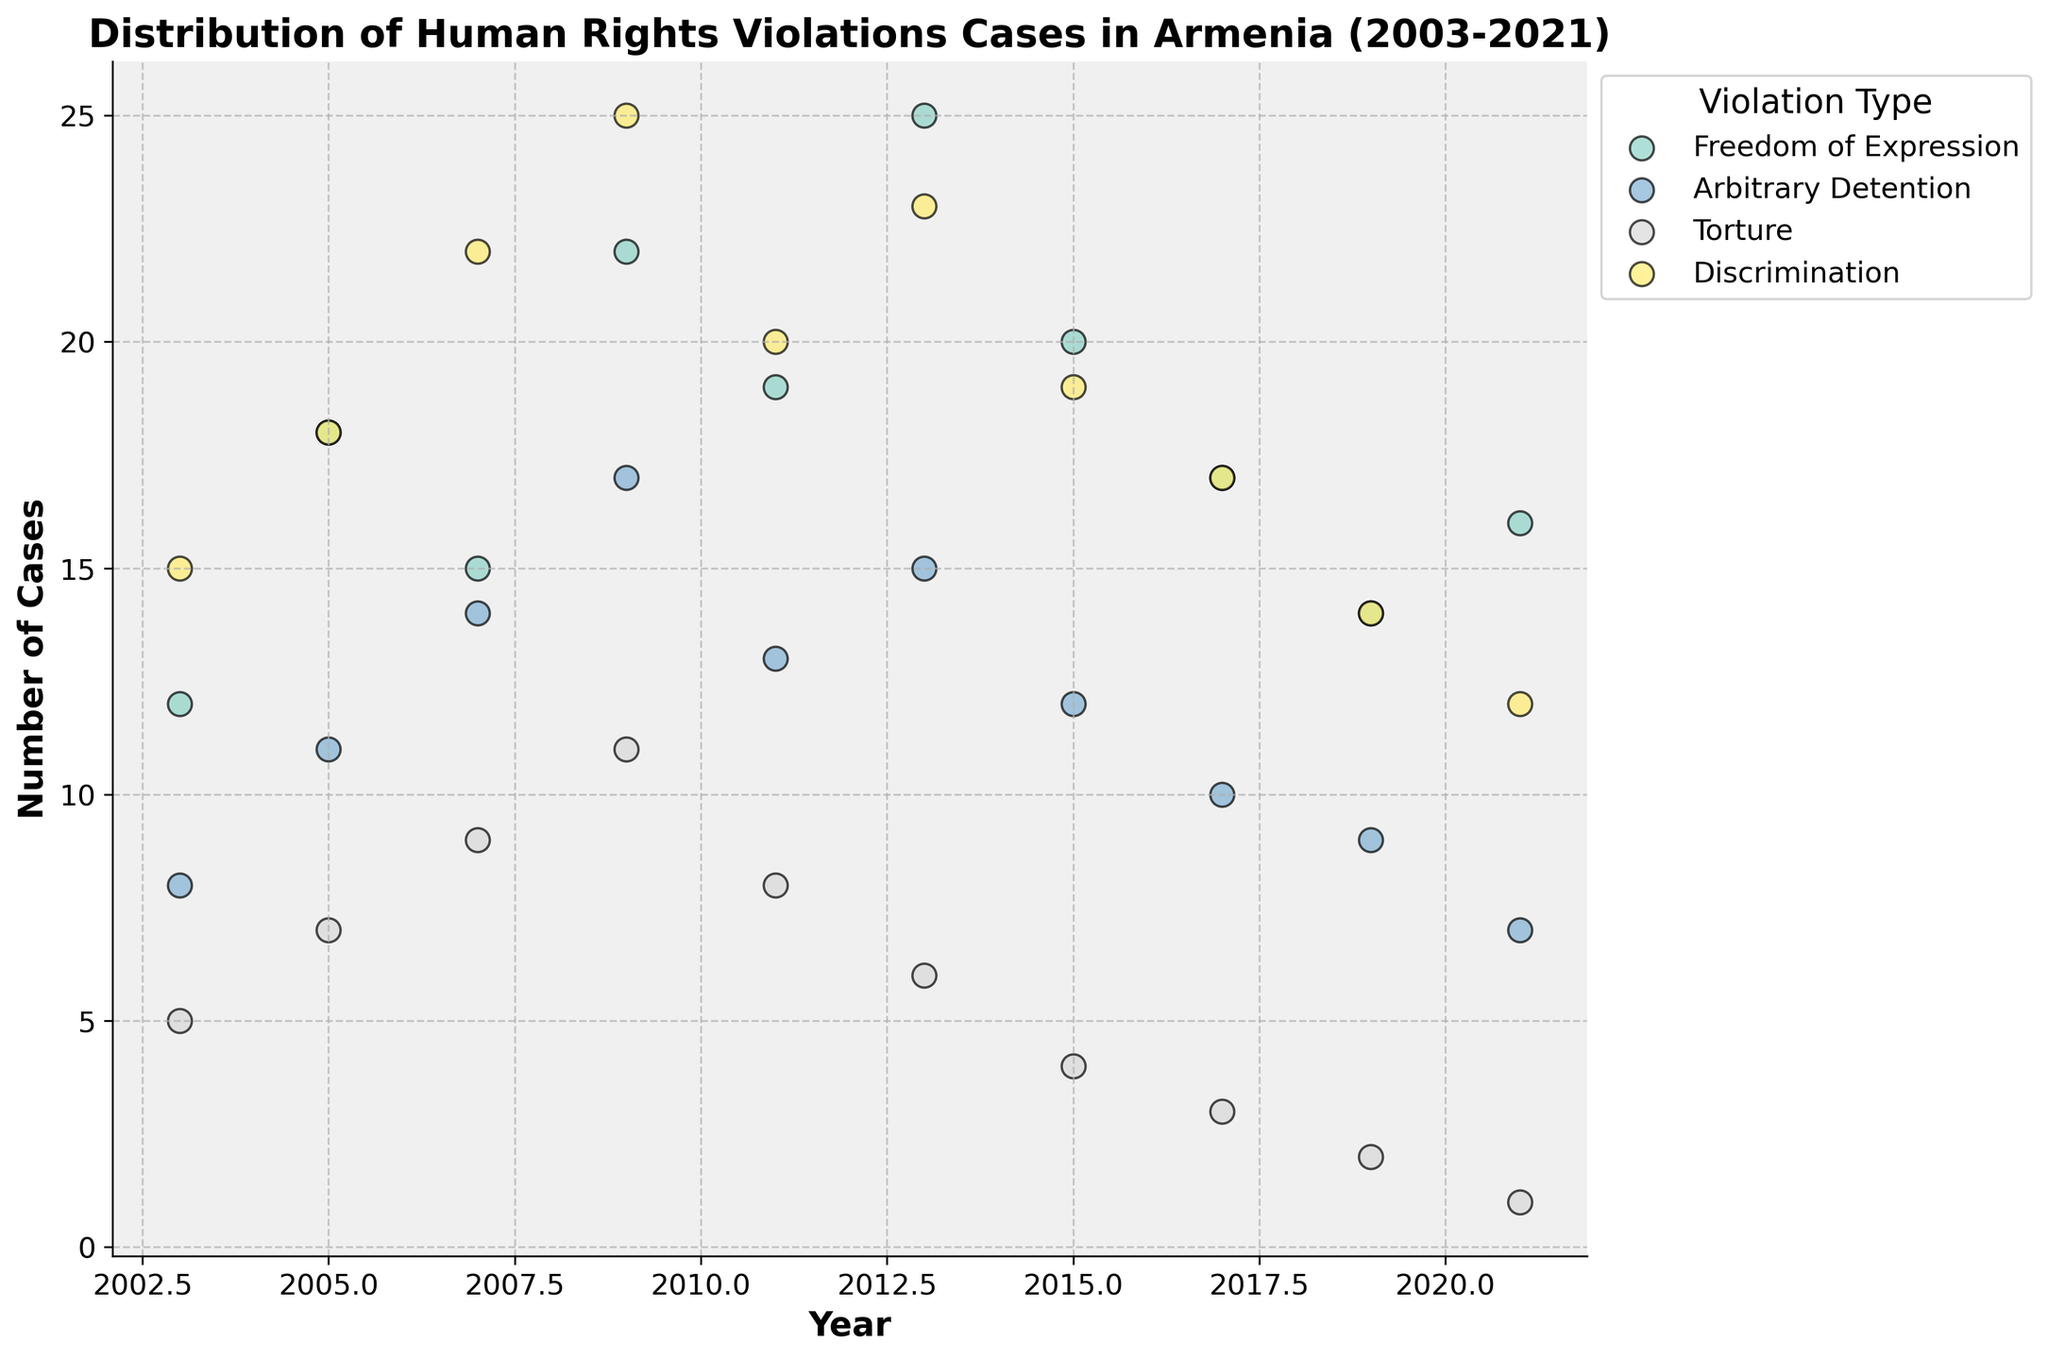What is the title of the plot? The title is clearly displayed at the top of the figure.
Answer: Distribution of Human Rights Violations Cases in Armenia (2003-2021) What is the highest number of Freedom of Expression cases reported in a single year? By looking at the vertical axis alongside the points marked for Freedom of Expression, the highest value can be observed.
Answer: 25 In which year did Torture cases drop below 5? Checking the vertical axis for Torture across all the years, the value drops below 5 after 2015.
Answer: 2017 How many different types of human rights violations are displayed? Each unique color represents a violation type listed in the legend at the right. Counting the items in the legend gives the total violation types.
Answer: 4 Which type of violation had the most cases reported in 2009? By aligning the year 2009 with the y-values across different color-coded points, the highest value can be identified.
Answer: Discrimination What is the average number of Arbitrary Detention cases from 2015 to 2021? Identifying the values for Arbitrary Detention from 2015, 2017, 2019, and 2021, then calculating their sum and dividing by 4. Average = (12 + 10 + 9 + 7) / 4
Answer: 9.5 Compare the trend for Freedom of Expression and Torture cases over the years. Observing the general direction and pattern of the points for these two types of violations shows opposite trends. While Freedom of Expression shows some fluctuation, Torture cases generally decrease.
Answer: Freedom of Expression fluctuates, Torture decreases Which violation type showed a decreasing trend from 2003 to 2021? Observing the plots, Torture is the most evident type with a consistent decreasing trend.
Answer: Torture What can you infer about the consistency of Discrimination cases compared to others? Analyzing the spread and fluctuation of Discrimination points over the years compared to other violation types shows it has more variability.
Answer: Discrimination shows higher variability Is there any year where Freedom of Expression and Discrimination cases were equal? Comparing the marks for these two types for each year to find if they overlap or match. One can see that the cases were equal for these two types in 2019.
Answer: 2019 